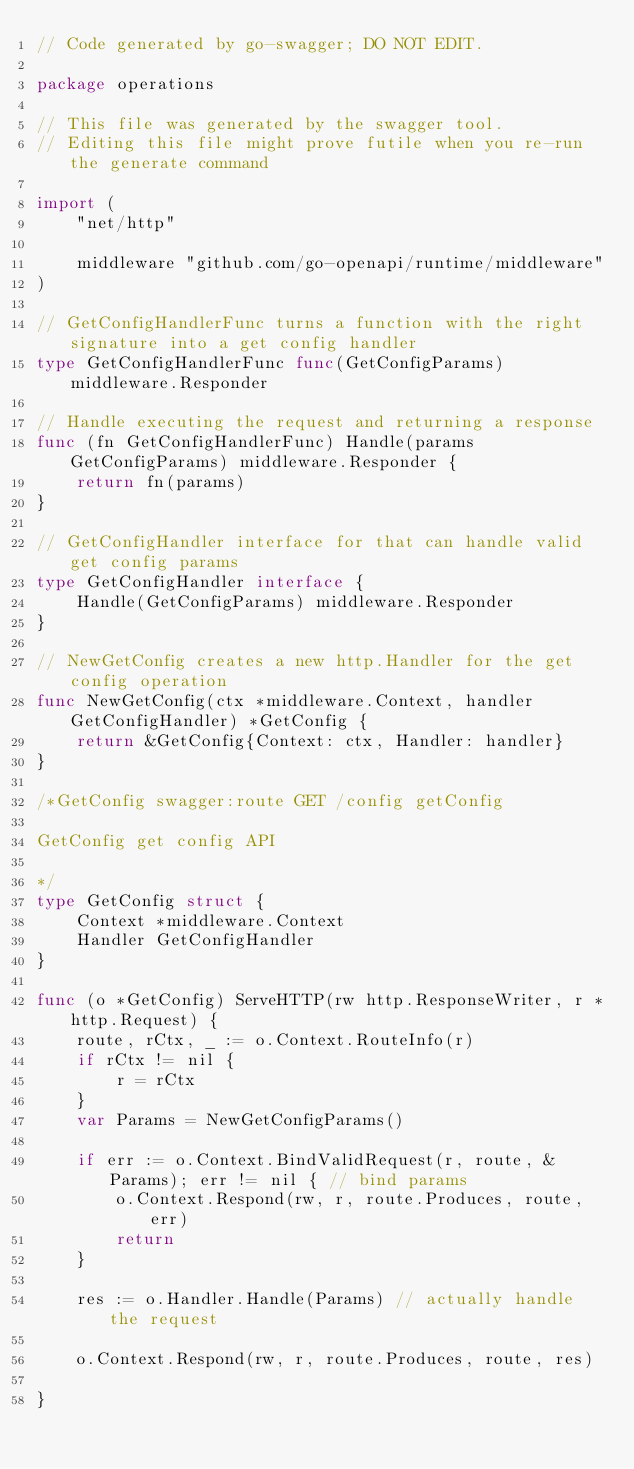<code> <loc_0><loc_0><loc_500><loc_500><_Go_>// Code generated by go-swagger; DO NOT EDIT.

package operations

// This file was generated by the swagger tool.
// Editing this file might prove futile when you re-run the generate command

import (
	"net/http"

	middleware "github.com/go-openapi/runtime/middleware"
)

// GetConfigHandlerFunc turns a function with the right signature into a get config handler
type GetConfigHandlerFunc func(GetConfigParams) middleware.Responder

// Handle executing the request and returning a response
func (fn GetConfigHandlerFunc) Handle(params GetConfigParams) middleware.Responder {
	return fn(params)
}

// GetConfigHandler interface for that can handle valid get config params
type GetConfigHandler interface {
	Handle(GetConfigParams) middleware.Responder
}

// NewGetConfig creates a new http.Handler for the get config operation
func NewGetConfig(ctx *middleware.Context, handler GetConfigHandler) *GetConfig {
	return &GetConfig{Context: ctx, Handler: handler}
}

/*GetConfig swagger:route GET /config getConfig

GetConfig get config API

*/
type GetConfig struct {
	Context *middleware.Context
	Handler GetConfigHandler
}

func (o *GetConfig) ServeHTTP(rw http.ResponseWriter, r *http.Request) {
	route, rCtx, _ := o.Context.RouteInfo(r)
	if rCtx != nil {
		r = rCtx
	}
	var Params = NewGetConfigParams()

	if err := o.Context.BindValidRequest(r, route, &Params); err != nil { // bind params
		o.Context.Respond(rw, r, route.Produces, route, err)
		return
	}

	res := o.Handler.Handle(Params) // actually handle the request

	o.Context.Respond(rw, r, route.Produces, route, res)

}
</code> 